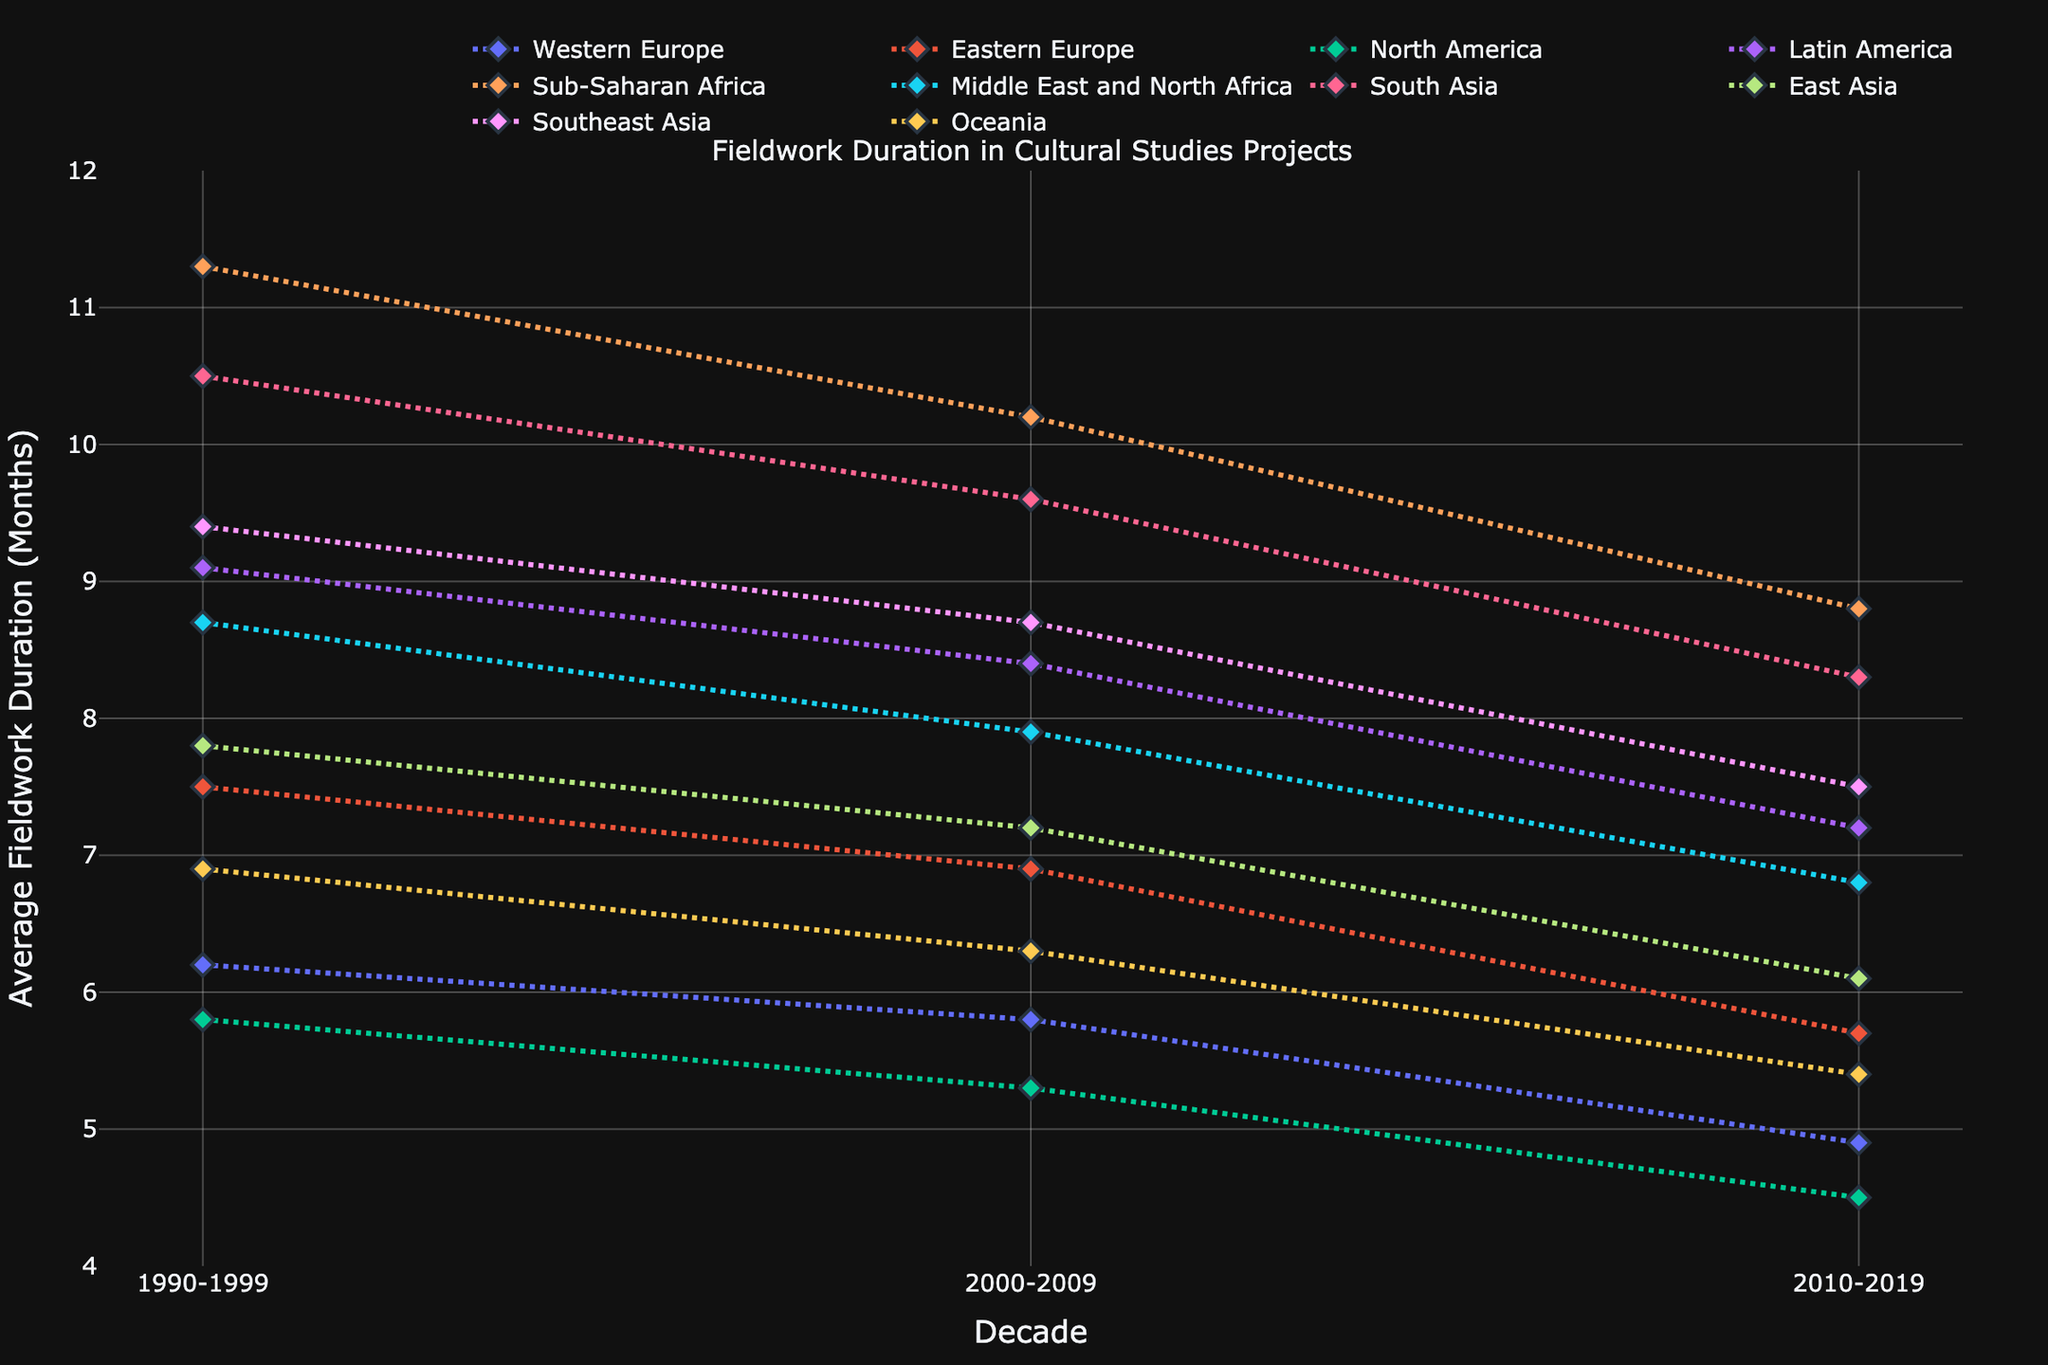What's the region with the highest average fieldwork duration in the 1990s? To determine this, observe the data lines for each region in the 1990s decade. Sub-Saharan Africa has the highest value at 11.3 months.
Answer: Sub-Saharan Africa How has the duration of fieldwork changed in Western Europe from the 1990s to the latest decade? Look at the data points for Western Europe across the decades. It starts at 6.2 months in the 1990s, drops to 5.8 in the 2000s, and further decreases to 4.9 in the 2010s.
Answer: Decreased Which region shows the most significant decrease in fieldwork duration from the 1990s to the 2010s? Calculate the difference in fieldwork duration between the 1990s and the 2010s for each region. Sub-Saharan Africa shows the most significant decrease of 11.3 - 8.8 = 2.5 months.
Answer: Sub-Saharan Africa During which decade did Southeast Asia have the highest fieldwork duration? Check the data points for Southeast Asia across the decades. The highest value is in the 1990s at 9.4 months.
Answer: 1990s Compare the fieldwork duration trends between North America and South Asia over the three decades. Examine the lines representing North America and South Asia. North America's fieldwork duration declines steadily from 5.8 to 5.3 to 4.5 months, while South Asia also declines but starts higher at 10.5, then 9.6, and finally 8.3 months.
Answer: Both regions have a decreasing trend What's the average decrease in fieldwork duration across all regions from the 1990s to the 2010s? Compute the difference for each region, then find the average: 
- Western Europe: 6.2 - 4.9 = 1.3
- Eastern Europe: 7.5 - 5.7 = 1.8
- North America: 5.8 - 4.5 = 1.3
- Latin America: 9.1 - 7.2 = 1.9
- Sub-Saharan Africa: 11.3 - 8.8 = 2.5
- Middle East and North Africa: 8.7 - 6.8 = 1.9
- South Asia: 10.5 - 8.3 = 2.2
- East Asia: 7.8 - 6.1 = 1.7
- Southeast Asia: 9.4 - 7.5 = 1.9
- Oceania: 6.9 - 5.4 = 1.5
Sum of decreases: 1.3 + 1.8 + 1.3 + 1.9 + 2.5 + 1.9 + 2.2 + 1.7 + 1.9 + 1.5 = 18
Average decrease: 18 / 10 = 1.8 months
Answer: 1.8 months Which two regions had the closest fieldwork durations in the 2000s? Examine the 2000s data values. Oceania at 6.3 months and Western Europe at 5.8 months are the closest, with a difference of 0.5 months.
Answer: Oceania and Western Europe How does the duration of fieldwork in Latin America in the 2010s compare to Eastern Europe in the same decade? Compare the data points for Latin America and Eastern Europe in the 2010s. Latin America has 7.2 months, and Eastern Europe has 5.7 months.
Answer: Latin America is higher What's the trend of fieldwork duration in East Asia over the decades? Look at East Asia's values across the decades. It decreases from 7.8 months in the 1990s to 7.2 months in the 2000s and further to 6.1 months in the 2010s.
Answer: Decreasing 